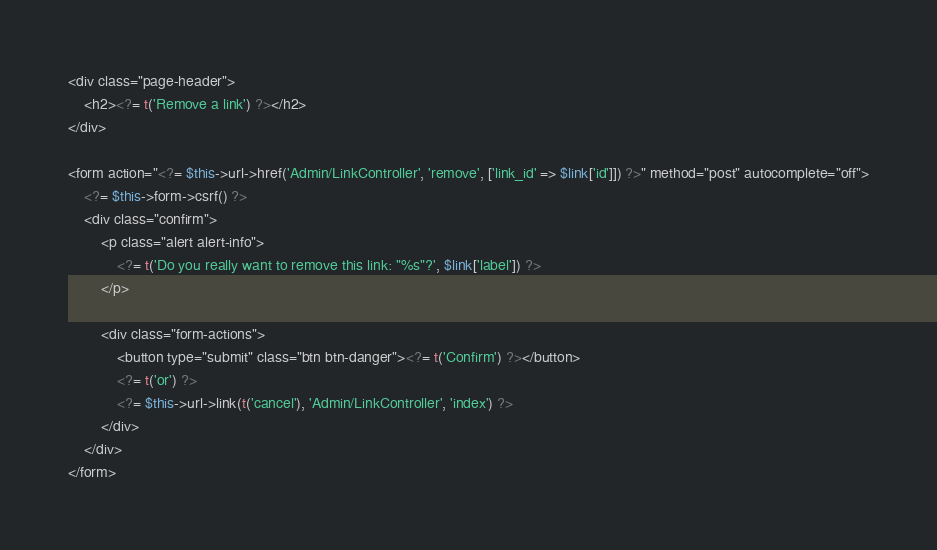Convert code to text. <code><loc_0><loc_0><loc_500><loc_500><_PHP_><div class="page-header">
    <h2><?= t('Remove a link') ?></h2>
</div>

<form action="<?= $this->url->href('Admin/LinkController', 'remove', ['link_id' => $link['id']]) ?>" method="post" autocomplete="off">
    <?= $this->form->csrf() ?>
    <div class="confirm">
        <p class="alert alert-info">
            <?= t('Do you really want to remove this link: "%s"?', $link['label']) ?>
        </p>

        <div class="form-actions">
            <button type="submit" class="btn btn-danger"><?= t('Confirm') ?></button>
            <?= t('or') ?>
            <?= $this->url->link(t('cancel'), 'Admin/LinkController', 'index') ?>
        </div>
    </div>
</form></code> 